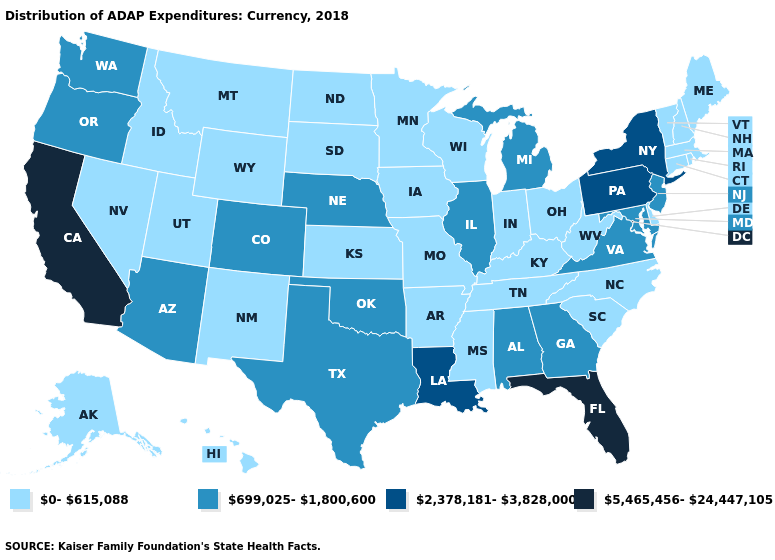Does Delaware have a lower value than Pennsylvania?
Write a very short answer. Yes. What is the value of Hawaii?
Keep it brief. 0-615,088. What is the value of Wisconsin?
Write a very short answer. 0-615,088. What is the value of Texas?
Short answer required. 699,025-1,800,600. What is the value of Indiana?
Concise answer only. 0-615,088. Which states have the lowest value in the USA?
Concise answer only. Alaska, Arkansas, Connecticut, Delaware, Hawaii, Idaho, Indiana, Iowa, Kansas, Kentucky, Maine, Massachusetts, Minnesota, Mississippi, Missouri, Montana, Nevada, New Hampshire, New Mexico, North Carolina, North Dakota, Ohio, Rhode Island, South Carolina, South Dakota, Tennessee, Utah, Vermont, West Virginia, Wisconsin, Wyoming. Does Missouri have the lowest value in the USA?
Short answer required. Yes. Is the legend a continuous bar?
Answer briefly. No. Does Washington have the lowest value in the USA?
Short answer required. No. Is the legend a continuous bar?
Give a very brief answer. No. Does New Jersey have the lowest value in the Northeast?
Short answer required. No. Does New Jersey have the same value as Virginia?
Concise answer only. Yes. What is the highest value in the South ?
Keep it brief. 5,465,456-24,447,105. Does the map have missing data?
Answer briefly. No. 